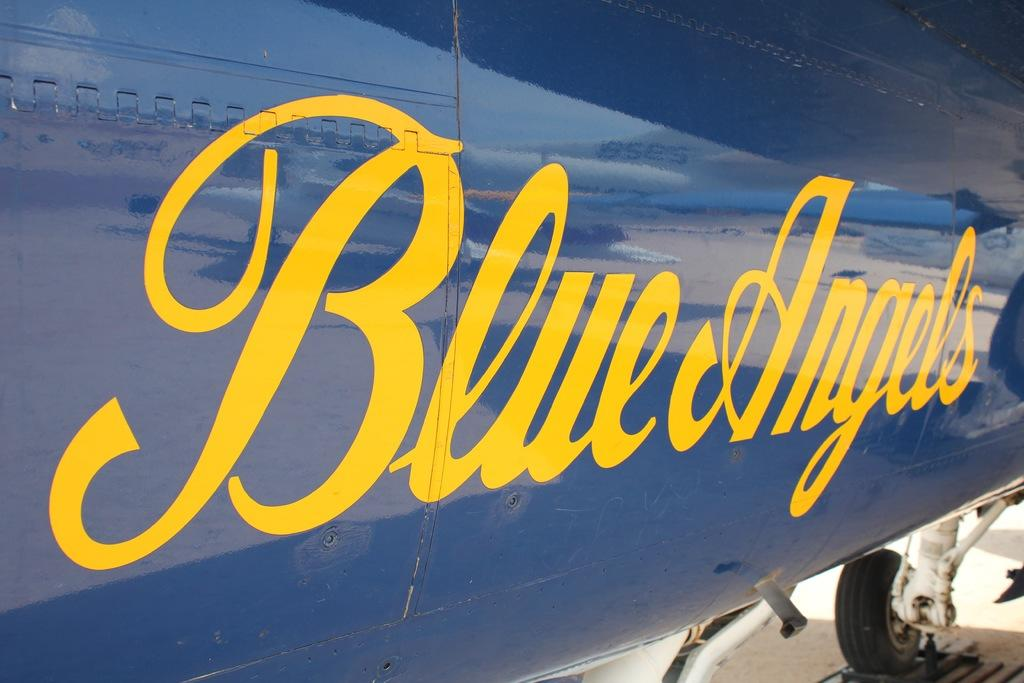What is written or displayed on the aircraft in the image? There are words on the aircraft. What can be seen in the reflection on the aircraft? There is a reflection of an airplane on the aircraft. What part of the environment is visible in the reflection? The sky is visible in the reflection. What type of minister is depicted in the image? There is no minister present in the image; it features an aircraft with words and a reflection. Can you tell me how many cents are visible in the image? There is no mention of currency or cents in the image; it focuses on an aircraft with words and a reflection. 